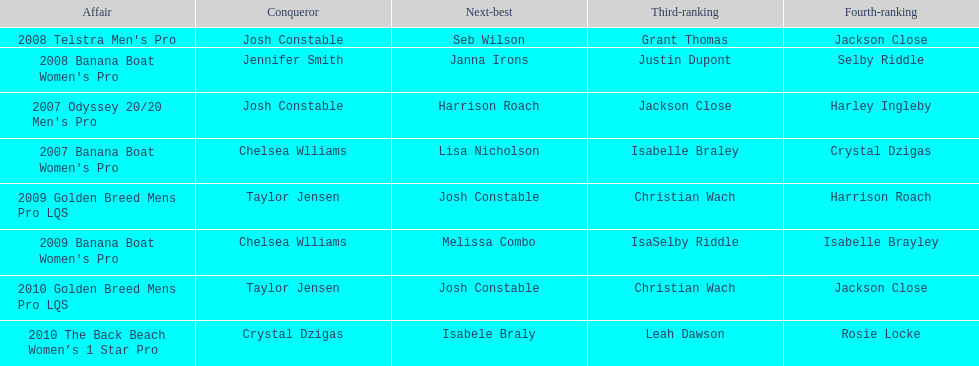At which event did taylor jensen first win? 2009 Golden Breed Mens Pro LQS. 